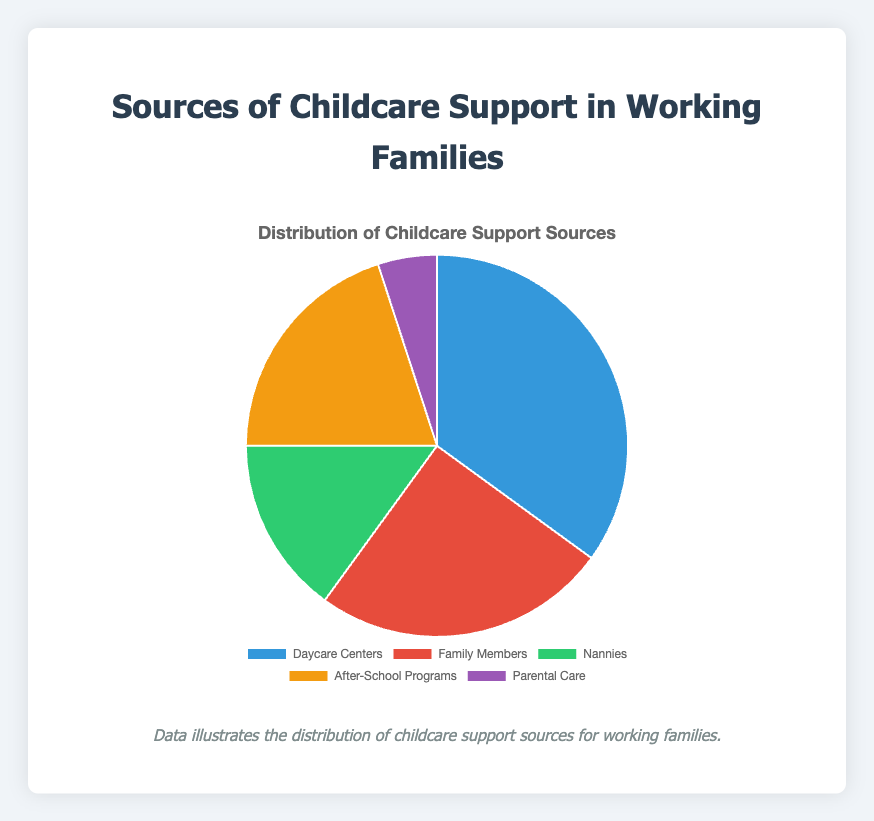Which source of childcare support is the most common? By looking at the pie chart, the largest section represents Daycare Centers, which have the highest percentage.
Answer: Daycare Centers What percentage of childcare support comes from family members and after-school programs combined? Adding the percentages of Family Members (25%) and After-School Programs (20%), we get 25% + 20% = 45%.
Answer: 45% Which two sources of childcare support combined are just shy of Daycare Centers? Adding Nannies (15%) and After-School Programs (20%) gives us 15% + 20% = 35%, which is equal to that of Daycare Centers. We need to pick the next two highest after nannies. Family Members (25%) + Parental Care (5%) gives us 30%, just shy of 35%.
Answer: Family Members and Parental Care Which source is least relied upon for childcare support? By examining the smallest slice in the pie chart, we see that Parental Care has the smallest percentage at 5%.
Answer: Parental Care Is the percentage of childcare support from nannies greater than that from after-school programs? By comparing the sections, we see that After-School Programs (20%) have a larger percentage than Nannies (15%).
Answer: No What is the difference in percentage between the most and least common sources of childcare support? Subtract the percentage of the smallest segment (Parental Care, 5%) from the largest segment (Daycare Centers, 35%). 35% - 5% = 30%.
Answer: 30% Which sources of childcare support take up more than half of the chart combined? Adding up Daycare Centers (35%), Family Members (25%) and After-School Programs (20%) gives 35% + 25% + 20% = 80%, which is more than half the chart.
Answer: Daycare Centers, Family Members, and After-School Programs How much larger is the percentage of family members providing childcare support compared to parental care? Subtract the percentage of Parental Care (5%) from Family Members (25%). 25% - 5% = 20%.
Answer: 20% 